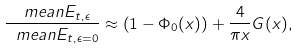Convert formula to latex. <formula><loc_0><loc_0><loc_500><loc_500>\frac { \ m e a n { E _ { t , \epsilon } } } { \ m e a n { E _ { t , \epsilon = 0 } } } \approx \left ( 1 - \Phi _ { 0 } ( x ) \right ) + \frac { 4 } { \pi x } G ( x ) ,</formula> 